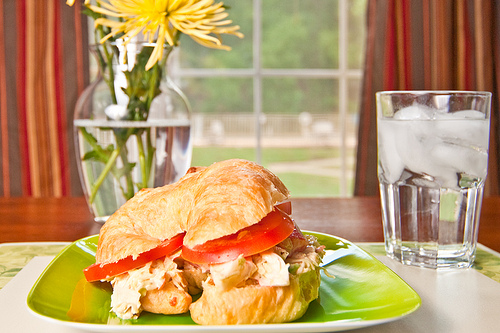What is the food that the chicken is on? The chicken is placed within a croissant sandwich. 